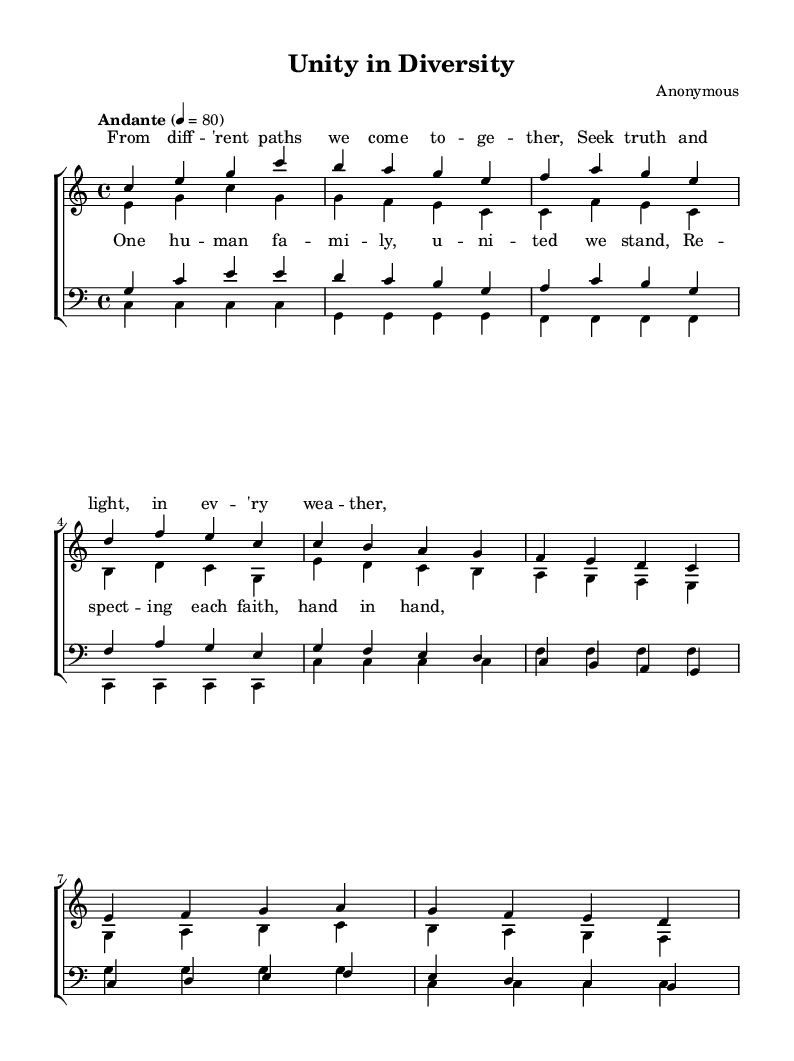What is the key signature of this music? The key signature is indicated at the beginning of the score. In this case, it shows no sharps or flats, which corresponds to C major.
Answer: C major What is the time signature of this piece? The time signature, located at the beginning in the score, indicates the number of beats in each measure. Here, it is shown as 4/4, meaning there are four beats per measure.
Answer: 4/4 What tempo marking is used for this composition? The tempo marking indicates the speed of the piece. In this score, it is marked "Andante" with a metronome marking of 80 beats per minute.
Answer: Andante 80 How many verses are present in this score? Upon examining the structure of the score, two sections for vocal parts labeled "verse" are observed for each voice type (soprano, alto, tenor, bass), leading to a total of four verses across the choir.
Answer: 4 What is the central theme of the lyrics in this piece? By reading the provided lyrics, the central theme emphasizes unity, diversity, and respect among different faiths, highlighting the idea of a united human family.
Answer: Unity in diversity Which vocal parts are present in this composition? The composition includes four distinct vocal parts: soprano, alto, tenor, and bass, as indicated in the score with separate staves for each part.
Answer: Soprano, alto, tenor, bass What is the overall message conveyed through the lyrics and composition? Analyzing the lyrics and the structure, the piece conveys a message of collaboration and respect among various faiths, suggesting an inclusive approach to spirituality and humanity's shared values.
Answer: Respecting each faith, hand in hand 